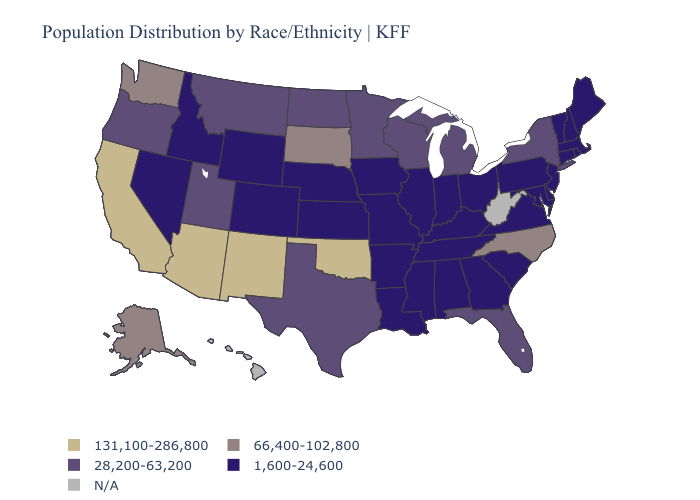Name the states that have a value in the range 66,400-102,800?
Short answer required. Alaska, North Carolina, South Dakota, Washington. Name the states that have a value in the range N/A?
Answer briefly. Hawaii, West Virginia. Does Michigan have the highest value in the USA?
Write a very short answer. No. What is the lowest value in the MidWest?
Give a very brief answer. 1,600-24,600. Name the states that have a value in the range 66,400-102,800?
Short answer required. Alaska, North Carolina, South Dakota, Washington. What is the lowest value in states that border Nevada?
Give a very brief answer. 1,600-24,600. Name the states that have a value in the range N/A?
Concise answer only. Hawaii, West Virginia. Name the states that have a value in the range N/A?
Write a very short answer. Hawaii, West Virginia. What is the value of Rhode Island?
Quick response, please. 1,600-24,600. Which states hav the highest value in the South?
Quick response, please. Oklahoma. Name the states that have a value in the range N/A?
Quick response, please. Hawaii, West Virginia. Among the states that border New Mexico , does Utah have the lowest value?
Answer briefly. No. What is the lowest value in states that border Iowa?
Quick response, please. 1,600-24,600. What is the value of Idaho?
Keep it brief. 1,600-24,600. 